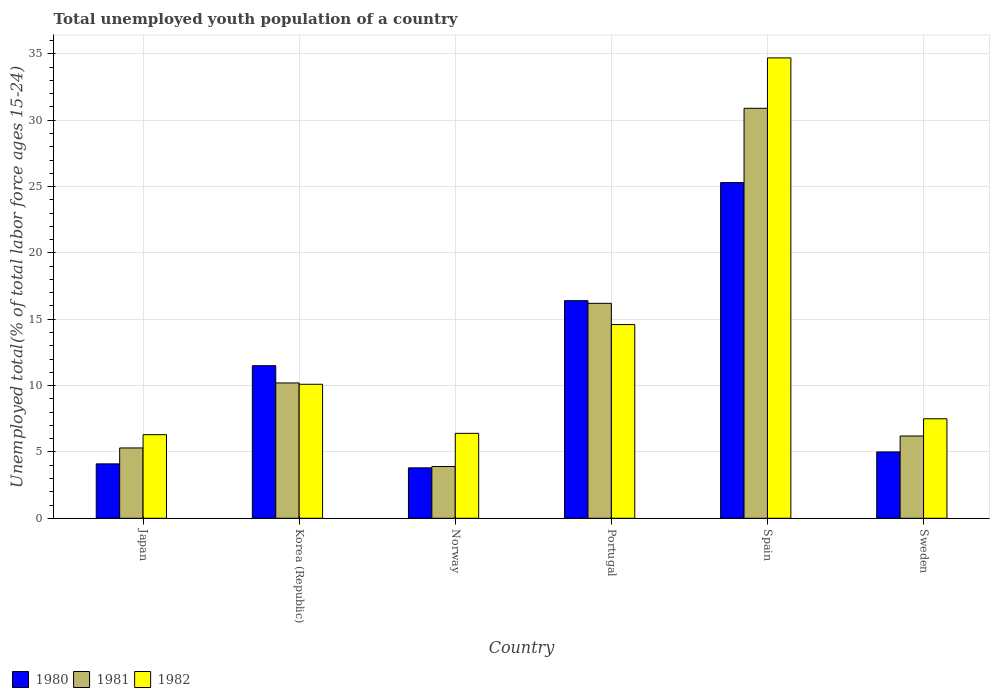How many different coloured bars are there?
Offer a very short reply. 3. Are the number of bars on each tick of the X-axis equal?
Offer a very short reply. Yes. How many bars are there on the 4th tick from the left?
Ensure brevity in your answer.  3. How many bars are there on the 5th tick from the right?
Ensure brevity in your answer.  3. What is the percentage of total unemployed youth population of a country in 1982 in Spain?
Your answer should be compact. 34.7. Across all countries, what is the maximum percentage of total unemployed youth population of a country in 1980?
Make the answer very short. 25.3. Across all countries, what is the minimum percentage of total unemployed youth population of a country in 1982?
Offer a terse response. 6.3. In which country was the percentage of total unemployed youth population of a country in 1981 minimum?
Offer a terse response. Norway. What is the total percentage of total unemployed youth population of a country in 1981 in the graph?
Keep it short and to the point. 72.7. What is the difference between the percentage of total unemployed youth population of a country in 1981 in Norway and that in Portugal?
Give a very brief answer. -12.3. What is the difference between the percentage of total unemployed youth population of a country in 1981 in Portugal and the percentage of total unemployed youth population of a country in 1980 in Korea (Republic)?
Your answer should be compact. 4.7. What is the average percentage of total unemployed youth population of a country in 1982 per country?
Ensure brevity in your answer.  13.27. What is the difference between the percentage of total unemployed youth population of a country of/in 1981 and percentage of total unemployed youth population of a country of/in 1980 in Japan?
Provide a short and direct response. 1.2. In how many countries, is the percentage of total unemployed youth population of a country in 1982 greater than 1 %?
Your answer should be compact. 6. What is the ratio of the percentage of total unemployed youth population of a country in 1982 in Spain to that in Sweden?
Provide a short and direct response. 4.63. Is the percentage of total unemployed youth population of a country in 1980 in Korea (Republic) less than that in Sweden?
Your response must be concise. No. Is the difference between the percentage of total unemployed youth population of a country in 1981 in Japan and Portugal greater than the difference between the percentage of total unemployed youth population of a country in 1980 in Japan and Portugal?
Keep it short and to the point. Yes. What is the difference between the highest and the second highest percentage of total unemployed youth population of a country in 1980?
Provide a succinct answer. -8.9. What is the difference between the highest and the lowest percentage of total unemployed youth population of a country in 1980?
Your response must be concise. 21.5. Is the sum of the percentage of total unemployed youth population of a country in 1981 in Korea (Republic) and Sweden greater than the maximum percentage of total unemployed youth population of a country in 1980 across all countries?
Provide a succinct answer. No. What does the 1st bar from the left in Sweden represents?
Provide a short and direct response. 1980. What does the 3rd bar from the right in Norway represents?
Make the answer very short. 1980. Is it the case that in every country, the sum of the percentage of total unemployed youth population of a country in 1982 and percentage of total unemployed youth population of a country in 1981 is greater than the percentage of total unemployed youth population of a country in 1980?
Offer a very short reply. Yes. How many bars are there?
Give a very brief answer. 18. How many countries are there in the graph?
Ensure brevity in your answer.  6. Are the values on the major ticks of Y-axis written in scientific E-notation?
Provide a succinct answer. No. Does the graph contain any zero values?
Your response must be concise. No. Does the graph contain grids?
Offer a terse response. Yes. How many legend labels are there?
Offer a very short reply. 3. What is the title of the graph?
Offer a very short reply. Total unemployed youth population of a country. What is the label or title of the Y-axis?
Give a very brief answer. Unemployed total(% of total labor force ages 15-24). What is the Unemployed total(% of total labor force ages 15-24) of 1980 in Japan?
Make the answer very short. 4.1. What is the Unemployed total(% of total labor force ages 15-24) in 1981 in Japan?
Your answer should be very brief. 5.3. What is the Unemployed total(% of total labor force ages 15-24) of 1982 in Japan?
Your response must be concise. 6.3. What is the Unemployed total(% of total labor force ages 15-24) in 1980 in Korea (Republic)?
Provide a short and direct response. 11.5. What is the Unemployed total(% of total labor force ages 15-24) of 1981 in Korea (Republic)?
Your answer should be very brief. 10.2. What is the Unemployed total(% of total labor force ages 15-24) of 1982 in Korea (Republic)?
Offer a terse response. 10.1. What is the Unemployed total(% of total labor force ages 15-24) in 1980 in Norway?
Offer a terse response. 3.8. What is the Unemployed total(% of total labor force ages 15-24) of 1981 in Norway?
Your answer should be very brief. 3.9. What is the Unemployed total(% of total labor force ages 15-24) of 1982 in Norway?
Your response must be concise. 6.4. What is the Unemployed total(% of total labor force ages 15-24) of 1980 in Portugal?
Offer a terse response. 16.4. What is the Unemployed total(% of total labor force ages 15-24) in 1981 in Portugal?
Your answer should be compact. 16.2. What is the Unemployed total(% of total labor force ages 15-24) of 1982 in Portugal?
Give a very brief answer. 14.6. What is the Unemployed total(% of total labor force ages 15-24) in 1980 in Spain?
Provide a short and direct response. 25.3. What is the Unemployed total(% of total labor force ages 15-24) in 1981 in Spain?
Provide a short and direct response. 30.9. What is the Unemployed total(% of total labor force ages 15-24) of 1982 in Spain?
Your answer should be compact. 34.7. What is the Unemployed total(% of total labor force ages 15-24) of 1980 in Sweden?
Give a very brief answer. 5. What is the Unemployed total(% of total labor force ages 15-24) of 1981 in Sweden?
Provide a succinct answer. 6.2. Across all countries, what is the maximum Unemployed total(% of total labor force ages 15-24) in 1980?
Provide a short and direct response. 25.3. Across all countries, what is the maximum Unemployed total(% of total labor force ages 15-24) in 1981?
Offer a terse response. 30.9. Across all countries, what is the maximum Unemployed total(% of total labor force ages 15-24) of 1982?
Ensure brevity in your answer.  34.7. Across all countries, what is the minimum Unemployed total(% of total labor force ages 15-24) of 1980?
Make the answer very short. 3.8. Across all countries, what is the minimum Unemployed total(% of total labor force ages 15-24) in 1981?
Give a very brief answer. 3.9. Across all countries, what is the minimum Unemployed total(% of total labor force ages 15-24) in 1982?
Your response must be concise. 6.3. What is the total Unemployed total(% of total labor force ages 15-24) in 1980 in the graph?
Keep it short and to the point. 66.1. What is the total Unemployed total(% of total labor force ages 15-24) in 1981 in the graph?
Keep it short and to the point. 72.7. What is the total Unemployed total(% of total labor force ages 15-24) in 1982 in the graph?
Your answer should be compact. 79.6. What is the difference between the Unemployed total(% of total labor force ages 15-24) of 1982 in Japan and that in Korea (Republic)?
Give a very brief answer. -3.8. What is the difference between the Unemployed total(% of total labor force ages 15-24) of 1981 in Japan and that in Norway?
Your response must be concise. 1.4. What is the difference between the Unemployed total(% of total labor force ages 15-24) of 1980 in Japan and that in Portugal?
Your response must be concise. -12.3. What is the difference between the Unemployed total(% of total labor force ages 15-24) of 1980 in Japan and that in Spain?
Provide a short and direct response. -21.2. What is the difference between the Unemployed total(% of total labor force ages 15-24) of 1981 in Japan and that in Spain?
Make the answer very short. -25.6. What is the difference between the Unemployed total(% of total labor force ages 15-24) in 1982 in Japan and that in Spain?
Ensure brevity in your answer.  -28.4. What is the difference between the Unemployed total(% of total labor force ages 15-24) in 1981 in Korea (Republic) and that in Norway?
Your answer should be very brief. 6.3. What is the difference between the Unemployed total(% of total labor force ages 15-24) of 1982 in Korea (Republic) and that in Norway?
Provide a succinct answer. 3.7. What is the difference between the Unemployed total(% of total labor force ages 15-24) of 1980 in Korea (Republic) and that in Portugal?
Your answer should be very brief. -4.9. What is the difference between the Unemployed total(% of total labor force ages 15-24) of 1981 in Korea (Republic) and that in Portugal?
Make the answer very short. -6. What is the difference between the Unemployed total(% of total labor force ages 15-24) of 1980 in Korea (Republic) and that in Spain?
Offer a very short reply. -13.8. What is the difference between the Unemployed total(% of total labor force ages 15-24) of 1981 in Korea (Republic) and that in Spain?
Provide a short and direct response. -20.7. What is the difference between the Unemployed total(% of total labor force ages 15-24) of 1982 in Korea (Republic) and that in Spain?
Keep it short and to the point. -24.6. What is the difference between the Unemployed total(% of total labor force ages 15-24) of 1982 in Korea (Republic) and that in Sweden?
Offer a terse response. 2.6. What is the difference between the Unemployed total(% of total labor force ages 15-24) in 1981 in Norway and that in Portugal?
Provide a short and direct response. -12.3. What is the difference between the Unemployed total(% of total labor force ages 15-24) of 1980 in Norway and that in Spain?
Make the answer very short. -21.5. What is the difference between the Unemployed total(% of total labor force ages 15-24) of 1982 in Norway and that in Spain?
Make the answer very short. -28.3. What is the difference between the Unemployed total(% of total labor force ages 15-24) in 1981 in Norway and that in Sweden?
Make the answer very short. -2.3. What is the difference between the Unemployed total(% of total labor force ages 15-24) in 1982 in Norway and that in Sweden?
Make the answer very short. -1.1. What is the difference between the Unemployed total(% of total labor force ages 15-24) of 1981 in Portugal and that in Spain?
Keep it short and to the point. -14.7. What is the difference between the Unemployed total(% of total labor force ages 15-24) of 1982 in Portugal and that in Spain?
Your response must be concise. -20.1. What is the difference between the Unemployed total(% of total labor force ages 15-24) of 1980 in Portugal and that in Sweden?
Offer a very short reply. 11.4. What is the difference between the Unemployed total(% of total labor force ages 15-24) in 1982 in Portugal and that in Sweden?
Make the answer very short. 7.1. What is the difference between the Unemployed total(% of total labor force ages 15-24) of 1980 in Spain and that in Sweden?
Give a very brief answer. 20.3. What is the difference between the Unemployed total(% of total labor force ages 15-24) of 1981 in Spain and that in Sweden?
Your answer should be compact. 24.7. What is the difference between the Unemployed total(% of total labor force ages 15-24) of 1982 in Spain and that in Sweden?
Your answer should be very brief. 27.2. What is the difference between the Unemployed total(% of total labor force ages 15-24) in 1980 in Japan and the Unemployed total(% of total labor force ages 15-24) in 1981 in Norway?
Offer a terse response. 0.2. What is the difference between the Unemployed total(% of total labor force ages 15-24) of 1981 in Japan and the Unemployed total(% of total labor force ages 15-24) of 1982 in Norway?
Offer a very short reply. -1.1. What is the difference between the Unemployed total(% of total labor force ages 15-24) in 1980 in Japan and the Unemployed total(% of total labor force ages 15-24) in 1981 in Portugal?
Your answer should be compact. -12.1. What is the difference between the Unemployed total(% of total labor force ages 15-24) of 1981 in Japan and the Unemployed total(% of total labor force ages 15-24) of 1982 in Portugal?
Provide a short and direct response. -9.3. What is the difference between the Unemployed total(% of total labor force ages 15-24) of 1980 in Japan and the Unemployed total(% of total labor force ages 15-24) of 1981 in Spain?
Ensure brevity in your answer.  -26.8. What is the difference between the Unemployed total(% of total labor force ages 15-24) in 1980 in Japan and the Unemployed total(% of total labor force ages 15-24) in 1982 in Spain?
Your response must be concise. -30.6. What is the difference between the Unemployed total(% of total labor force ages 15-24) of 1981 in Japan and the Unemployed total(% of total labor force ages 15-24) of 1982 in Spain?
Make the answer very short. -29.4. What is the difference between the Unemployed total(% of total labor force ages 15-24) in 1980 in Japan and the Unemployed total(% of total labor force ages 15-24) in 1981 in Sweden?
Your answer should be compact. -2.1. What is the difference between the Unemployed total(% of total labor force ages 15-24) of 1981 in Japan and the Unemployed total(% of total labor force ages 15-24) of 1982 in Sweden?
Give a very brief answer. -2.2. What is the difference between the Unemployed total(% of total labor force ages 15-24) of 1980 in Korea (Republic) and the Unemployed total(% of total labor force ages 15-24) of 1982 in Norway?
Keep it short and to the point. 5.1. What is the difference between the Unemployed total(% of total labor force ages 15-24) in 1981 in Korea (Republic) and the Unemployed total(% of total labor force ages 15-24) in 1982 in Portugal?
Your answer should be compact. -4.4. What is the difference between the Unemployed total(% of total labor force ages 15-24) of 1980 in Korea (Republic) and the Unemployed total(% of total labor force ages 15-24) of 1981 in Spain?
Offer a very short reply. -19.4. What is the difference between the Unemployed total(% of total labor force ages 15-24) in 1980 in Korea (Republic) and the Unemployed total(% of total labor force ages 15-24) in 1982 in Spain?
Provide a short and direct response. -23.2. What is the difference between the Unemployed total(% of total labor force ages 15-24) of 1981 in Korea (Republic) and the Unemployed total(% of total labor force ages 15-24) of 1982 in Spain?
Your answer should be very brief. -24.5. What is the difference between the Unemployed total(% of total labor force ages 15-24) of 1981 in Korea (Republic) and the Unemployed total(% of total labor force ages 15-24) of 1982 in Sweden?
Keep it short and to the point. 2.7. What is the difference between the Unemployed total(% of total labor force ages 15-24) in 1980 in Norway and the Unemployed total(% of total labor force ages 15-24) in 1981 in Spain?
Ensure brevity in your answer.  -27.1. What is the difference between the Unemployed total(% of total labor force ages 15-24) in 1980 in Norway and the Unemployed total(% of total labor force ages 15-24) in 1982 in Spain?
Provide a short and direct response. -30.9. What is the difference between the Unemployed total(% of total labor force ages 15-24) in 1981 in Norway and the Unemployed total(% of total labor force ages 15-24) in 1982 in Spain?
Give a very brief answer. -30.8. What is the difference between the Unemployed total(% of total labor force ages 15-24) in 1980 in Norway and the Unemployed total(% of total labor force ages 15-24) in 1981 in Sweden?
Provide a succinct answer. -2.4. What is the difference between the Unemployed total(% of total labor force ages 15-24) in 1980 in Norway and the Unemployed total(% of total labor force ages 15-24) in 1982 in Sweden?
Make the answer very short. -3.7. What is the difference between the Unemployed total(% of total labor force ages 15-24) in 1980 in Portugal and the Unemployed total(% of total labor force ages 15-24) in 1981 in Spain?
Provide a succinct answer. -14.5. What is the difference between the Unemployed total(% of total labor force ages 15-24) in 1980 in Portugal and the Unemployed total(% of total labor force ages 15-24) in 1982 in Spain?
Keep it short and to the point. -18.3. What is the difference between the Unemployed total(% of total labor force ages 15-24) of 1981 in Portugal and the Unemployed total(% of total labor force ages 15-24) of 1982 in Spain?
Offer a terse response. -18.5. What is the difference between the Unemployed total(% of total labor force ages 15-24) of 1980 in Spain and the Unemployed total(% of total labor force ages 15-24) of 1982 in Sweden?
Your response must be concise. 17.8. What is the difference between the Unemployed total(% of total labor force ages 15-24) in 1981 in Spain and the Unemployed total(% of total labor force ages 15-24) in 1982 in Sweden?
Offer a very short reply. 23.4. What is the average Unemployed total(% of total labor force ages 15-24) of 1980 per country?
Keep it short and to the point. 11.02. What is the average Unemployed total(% of total labor force ages 15-24) in 1981 per country?
Provide a succinct answer. 12.12. What is the average Unemployed total(% of total labor force ages 15-24) of 1982 per country?
Offer a terse response. 13.27. What is the difference between the Unemployed total(% of total labor force ages 15-24) in 1980 and Unemployed total(% of total labor force ages 15-24) in 1982 in Japan?
Make the answer very short. -2.2. What is the difference between the Unemployed total(% of total labor force ages 15-24) of 1981 and Unemployed total(% of total labor force ages 15-24) of 1982 in Japan?
Give a very brief answer. -1. What is the difference between the Unemployed total(% of total labor force ages 15-24) of 1980 and Unemployed total(% of total labor force ages 15-24) of 1982 in Korea (Republic)?
Offer a terse response. 1.4. What is the difference between the Unemployed total(% of total labor force ages 15-24) of 1981 and Unemployed total(% of total labor force ages 15-24) of 1982 in Korea (Republic)?
Offer a terse response. 0.1. What is the difference between the Unemployed total(% of total labor force ages 15-24) in 1980 and Unemployed total(% of total labor force ages 15-24) in 1982 in Norway?
Your response must be concise. -2.6. What is the difference between the Unemployed total(% of total labor force ages 15-24) in 1980 and Unemployed total(% of total labor force ages 15-24) in 1981 in Portugal?
Your answer should be very brief. 0.2. What is the difference between the Unemployed total(% of total labor force ages 15-24) in 1980 and Unemployed total(% of total labor force ages 15-24) in 1982 in Spain?
Make the answer very short. -9.4. What is the difference between the Unemployed total(% of total labor force ages 15-24) in 1981 and Unemployed total(% of total labor force ages 15-24) in 1982 in Spain?
Offer a terse response. -3.8. What is the difference between the Unemployed total(% of total labor force ages 15-24) in 1980 and Unemployed total(% of total labor force ages 15-24) in 1981 in Sweden?
Offer a terse response. -1.2. What is the difference between the Unemployed total(% of total labor force ages 15-24) of 1981 and Unemployed total(% of total labor force ages 15-24) of 1982 in Sweden?
Ensure brevity in your answer.  -1.3. What is the ratio of the Unemployed total(% of total labor force ages 15-24) in 1980 in Japan to that in Korea (Republic)?
Provide a succinct answer. 0.36. What is the ratio of the Unemployed total(% of total labor force ages 15-24) in 1981 in Japan to that in Korea (Republic)?
Ensure brevity in your answer.  0.52. What is the ratio of the Unemployed total(% of total labor force ages 15-24) of 1982 in Japan to that in Korea (Republic)?
Make the answer very short. 0.62. What is the ratio of the Unemployed total(% of total labor force ages 15-24) in 1980 in Japan to that in Norway?
Provide a short and direct response. 1.08. What is the ratio of the Unemployed total(% of total labor force ages 15-24) of 1981 in Japan to that in Norway?
Offer a terse response. 1.36. What is the ratio of the Unemployed total(% of total labor force ages 15-24) of 1982 in Japan to that in Norway?
Provide a succinct answer. 0.98. What is the ratio of the Unemployed total(% of total labor force ages 15-24) in 1980 in Japan to that in Portugal?
Keep it short and to the point. 0.25. What is the ratio of the Unemployed total(% of total labor force ages 15-24) of 1981 in Japan to that in Portugal?
Your answer should be very brief. 0.33. What is the ratio of the Unemployed total(% of total labor force ages 15-24) of 1982 in Japan to that in Portugal?
Your answer should be compact. 0.43. What is the ratio of the Unemployed total(% of total labor force ages 15-24) in 1980 in Japan to that in Spain?
Your response must be concise. 0.16. What is the ratio of the Unemployed total(% of total labor force ages 15-24) of 1981 in Japan to that in Spain?
Your answer should be compact. 0.17. What is the ratio of the Unemployed total(% of total labor force ages 15-24) in 1982 in Japan to that in Spain?
Provide a short and direct response. 0.18. What is the ratio of the Unemployed total(% of total labor force ages 15-24) in 1980 in Japan to that in Sweden?
Give a very brief answer. 0.82. What is the ratio of the Unemployed total(% of total labor force ages 15-24) in 1981 in Japan to that in Sweden?
Keep it short and to the point. 0.85. What is the ratio of the Unemployed total(% of total labor force ages 15-24) in 1982 in Japan to that in Sweden?
Offer a terse response. 0.84. What is the ratio of the Unemployed total(% of total labor force ages 15-24) in 1980 in Korea (Republic) to that in Norway?
Give a very brief answer. 3.03. What is the ratio of the Unemployed total(% of total labor force ages 15-24) in 1981 in Korea (Republic) to that in Norway?
Make the answer very short. 2.62. What is the ratio of the Unemployed total(% of total labor force ages 15-24) in 1982 in Korea (Republic) to that in Norway?
Give a very brief answer. 1.58. What is the ratio of the Unemployed total(% of total labor force ages 15-24) in 1980 in Korea (Republic) to that in Portugal?
Keep it short and to the point. 0.7. What is the ratio of the Unemployed total(% of total labor force ages 15-24) of 1981 in Korea (Republic) to that in Portugal?
Your answer should be very brief. 0.63. What is the ratio of the Unemployed total(% of total labor force ages 15-24) of 1982 in Korea (Republic) to that in Portugal?
Provide a succinct answer. 0.69. What is the ratio of the Unemployed total(% of total labor force ages 15-24) of 1980 in Korea (Republic) to that in Spain?
Make the answer very short. 0.45. What is the ratio of the Unemployed total(% of total labor force ages 15-24) in 1981 in Korea (Republic) to that in Spain?
Ensure brevity in your answer.  0.33. What is the ratio of the Unemployed total(% of total labor force ages 15-24) of 1982 in Korea (Republic) to that in Spain?
Offer a very short reply. 0.29. What is the ratio of the Unemployed total(% of total labor force ages 15-24) in 1981 in Korea (Republic) to that in Sweden?
Offer a very short reply. 1.65. What is the ratio of the Unemployed total(% of total labor force ages 15-24) of 1982 in Korea (Republic) to that in Sweden?
Ensure brevity in your answer.  1.35. What is the ratio of the Unemployed total(% of total labor force ages 15-24) in 1980 in Norway to that in Portugal?
Offer a terse response. 0.23. What is the ratio of the Unemployed total(% of total labor force ages 15-24) of 1981 in Norway to that in Portugal?
Make the answer very short. 0.24. What is the ratio of the Unemployed total(% of total labor force ages 15-24) of 1982 in Norway to that in Portugal?
Offer a terse response. 0.44. What is the ratio of the Unemployed total(% of total labor force ages 15-24) of 1980 in Norway to that in Spain?
Make the answer very short. 0.15. What is the ratio of the Unemployed total(% of total labor force ages 15-24) in 1981 in Norway to that in Spain?
Provide a short and direct response. 0.13. What is the ratio of the Unemployed total(% of total labor force ages 15-24) in 1982 in Norway to that in Spain?
Your answer should be very brief. 0.18. What is the ratio of the Unemployed total(% of total labor force ages 15-24) of 1980 in Norway to that in Sweden?
Provide a succinct answer. 0.76. What is the ratio of the Unemployed total(% of total labor force ages 15-24) in 1981 in Norway to that in Sweden?
Give a very brief answer. 0.63. What is the ratio of the Unemployed total(% of total labor force ages 15-24) of 1982 in Norway to that in Sweden?
Offer a terse response. 0.85. What is the ratio of the Unemployed total(% of total labor force ages 15-24) in 1980 in Portugal to that in Spain?
Your answer should be compact. 0.65. What is the ratio of the Unemployed total(% of total labor force ages 15-24) in 1981 in Portugal to that in Spain?
Ensure brevity in your answer.  0.52. What is the ratio of the Unemployed total(% of total labor force ages 15-24) in 1982 in Portugal to that in Spain?
Offer a very short reply. 0.42. What is the ratio of the Unemployed total(% of total labor force ages 15-24) of 1980 in Portugal to that in Sweden?
Provide a short and direct response. 3.28. What is the ratio of the Unemployed total(% of total labor force ages 15-24) of 1981 in Portugal to that in Sweden?
Keep it short and to the point. 2.61. What is the ratio of the Unemployed total(% of total labor force ages 15-24) in 1982 in Portugal to that in Sweden?
Provide a short and direct response. 1.95. What is the ratio of the Unemployed total(% of total labor force ages 15-24) in 1980 in Spain to that in Sweden?
Provide a succinct answer. 5.06. What is the ratio of the Unemployed total(% of total labor force ages 15-24) of 1981 in Spain to that in Sweden?
Provide a short and direct response. 4.98. What is the ratio of the Unemployed total(% of total labor force ages 15-24) of 1982 in Spain to that in Sweden?
Provide a succinct answer. 4.63. What is the difference between the highest and the second highest Unemployed total(% of total labor force ages 15-24) of 1982?
Give a very brief answer. 20.1. What is the difference between the highest and the lowest Unemployed total(% of total labor force ages 15-24) in 1980?
Offer a very short reply. 21.5. What is the difference between the highest and the lowest Unemployed total(% of total labor force ages 15-24) in 1981?
Ensure brevity in your answer.  27. What is the difference between the highest and the lowest Unemployed total(% of total labor force ages 15-24) in 1982?
Make the answer very short. 28.4. 